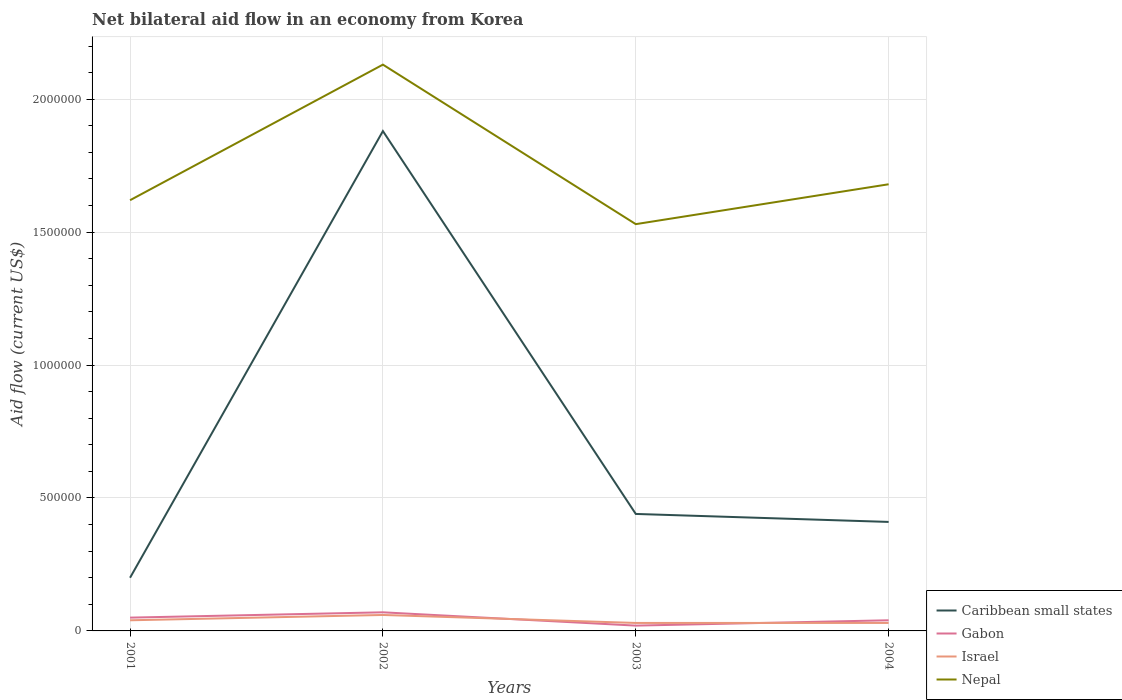How many different coloured lines are there?
Keep it short and to the point. 4. Does the line corresponding to Nepal intersect with the line corresponding to Gabon?
Your answer should be very brief. No. Across all years, what is the maximum net bilateral aid flow in Nepal?
Keep it short and to the point. 1.53e+06. In which year was the net bilateral aid flow in Israel maximum?
Provide a short and direct response. 2003. Is the net bilateral aid flow in Gabon strictly greater than the net bilateral aid flow in Israel over the years?
Provide a short and direct response. No. How many lines are there?
Ensure brevity in your answer.  4. What is the difference between two consecutive major ticks on the Y-axis?
Offer a terse response. 5.00e+05. Are the values on the major ticks of Y-axis written in scientific E-notation?
Provide a succinct answer. No. How many legend labels are there?
Your answer should be very brief. 4. What is the title of the graph?
Make the answer very short. Net bilateral aid flow in an economy from Korea. What is the label or title of the X-axis?
Ensure brevity in your answer.  Years. What is the Aid flow (current US$) in Caribbean small states in 2001?
Make the answer very short. 2.00e+05. What is the Aid flow (current US$) in Israel in 2001?
Keep it short and to the point. 4.00e+04. What is the Aid flow (current US$) of Nepal in 2001?
Your answer should be compact. 1.62e+06. What is the Aid flow (current US$) of Caribbean small states in 2002?
Offer a very short reply. 1.88e+06. What is the Aid flow (current US$) in Nepal in 2002?
Make the answer very short. 2.13e+06. What is the Aid flow (current US$) in Caribbean small states in 2003?
Your response must be concise. 4.40e+05. What is the Aid flow (current US$) of Gabon in 2003?
Your answer should be compact. 2.00e+04. What is the Aid flow (current US$) of Israel in 2003?
Ensure brevity in your answer.  3.00e+04. What is the Aid flow (current US$) in Nepal in 2003?
Make the answer very short. 1.53e+06. What is the Aid flow (current US$) of Caribbean small states in 2004?
Make the answer very short. 4.10e+05. What is the Aid flow (current US$) of Gabon in 2004?
Ensure brevity in your answer.  4.00e+04. What is the Aid flow (current US$) in Nepal in 2004?
Make the answer very short. 1.68e+06. Across all years, what is the maximum Aid flow (current US$) in Caribbean small states?
Your answer should be compact. 1.88e+06. Across all years, what is the maximum Aid flow (current US$) in Israel?
Ensure brevity in your answer.  6.00e+04. Across all years, what is the maximum Aid flow (current US$) in Nepal?
Provide a short and direct response. 2.13e+06. Across all years, what is the minimum Aid flow (current US$) in Gabon?
Give a very brief answer. 2.00e+04. Across all years, what is the minimum Aid flow (current US$) in Israel?
Your response must be concise. 3.00e+04. Across all years, what is the minimum Aid flow (current US$) of Nepal?
Offer a very short reply. 1.53e+06. What is the total Aid flow (current US$) of Caribbean small states in the graph?
Provide a short and direct response. 2.93e+06. What is the total Aid flow (current US$) of Gabon in the graph?
Offer a terse response. 1.80e+05. What is the total Aid flow (current US$) of Israel in the graph?
Provide a short and direct response. 1.60e+05. What is the total Aid flow (current US$) of Nepal in the graph?
Your response must be concise. 6.96e+06. What is the difference between the Aid flow (current US$) of Caribbean small states in 2001 and that in 2002?
Provide a succinct answer. -1.68e+06. What is the difference between the Aid flow (current US$) in Israel in 2001 and that in 2002?
Ensure brevity in your answer.  -2.00e+04. What is the difference between the Aid flow (current US$) of Nepal in 2001 and that in 2002?
Offer a very short reply. -5.10e+05. What is the difference between the Aid flow (current US$) of Gabon in 2001 and that in 2003?
Provide a short and direct response. 3.00e+04. What is the difference between the Aid flow (current US$) in Israel in 2001 and that in 2003?
Your response must be concise. 10000. What is the difference between the Aid flow (current US$) in Caribbean small states in 2001 and that in 2004?
Provide a short and direct response. -2.10e+05. What is the difference between the Aid flow (current US$) of Israel in 2001 and that in 2004?
Keep it short and to the point. 10000. What is the difference between the Aid flow (current US$) in Caribbean small states in 2002 and that in 2003?
Keep it short and to the point. 1.44e+06. What is the difference between the Aid flow (current US$) of Gabon in 2002 and that in 2003?
Offer a terse response. 5.00e+04. What is the difference between the Aid flow (current US$) in Caribbean small states in 2002 and that in 2004?
Give a very brief answer. 1.47e+06. What is the difference between the Aid flow (current US$) in Nepal in 2002 and that in 2004?
Offer a very short reply. 4.50e+05. What is the difference between the Aid flow (current US$) of Caribbean small states in 2003 and that in 2004?
Your answer should be very brief. 3.00e+04. What is the difference between the Aid flow (current US$) of Gabon in 2003 and that in 2004?
Your response must be concise. -2.00e+04. What is the difference between the Aid flow (current US$) in Nepal in 2003 and that in 2004?
Provide a short and direct response. -1.50e+05. What is the difference between the Aid flow (current US$) in Caribbean small states in 2001 and the Aid flow (current US$) in Nepal in 2002?
Your response must be concise. -1.93e+06. What is the difference between the Aid flow (current US$) of Gabon in 2001 and the Aid flow (current US$) of Israel in 2002?
Give a very brief answer. -10000. What is the difference between the Aid flow (current US$) of Gabon in 2001 and the Aid flow (current US$) of Nepal in 2002?
Keep it short and to the point. -2.08e+06. What is the difference between the Aid flow (current US$) in Israel in 2001 and the Aid flow (current US$) in Nepal in 2002?
Make the answer very short. -2.09e+06. What is the difference between the Aid flow (current US$) of Caribbean small states in 2001 and the Aid flow (current US$) of Gabon in 2003?
Give a very brief answer. 1.80e+05. What is the difference between the Aid flow (current US$) of Caribbean small states in 2001 and the Aid flow (current US$) of Israel in 2003?
Provide a succinct answer. 1.70e+05. What is the difference between the Aid flow (current US$) in Caribbean small states in 2001 and the Aid flow (current US$) in Nepal in 2003?
Your answer should be very brief. -1.33e+06. What is the difference between the Aid flow (current US$) in Gabon in 2001 and the Aid flow (current US$) in Israel in 2003?
Your answer should be very brief. 2.00e+04. What is the difference between the Aid flow (current US$) of Gabon in 2001 and the Aid flow (current US$) of Nepal in 2003?
Keep it short and to the point. -1.48e+06. What is the difference between the Aid flow (current US$) of Israel in 2001 and the Aid flow (current US$) of Nepal in 2003?
Provide a succinct answer. -1.49e+06. What is the difference between the Aid flow (current US$) of Caribbean small states in 2001 and the Aid flow (current US$) of Gabon in 2004?
Your response must be concise. 1.60e+05. What is the difference between the Aid flow (current US$) of Caribbean small states in 2001 and the Aid flow (current US$) of Nepal in 2004?
Keep it short and to the point. -1.48e+06. What is the difference between the Aid flow (current US$) of Gabon in 2001 and the Aid flow (current US$) of Israel in 2004?
Offer a terse response. 2.00e+04. What is the difference between the Aid flow (current US$) of Gabon in 2001 and the Aid flow (current US$) of Nepal in 2004?
Ensure brevity in your answer.  -1.63e+06. What is the difference between the Aid flow (current US$) in Israel in 2001 and the Aid flow (current US$) in Nepal in 2004?
Offer a very short reply. -1.64e+06. What is the difference between the Aid flow (current US$) in Caribbean small states in 2002 and the Aid flow (current US$) in Gabon in 2003?
Make the answer very short. 1.86e+06. What is the difference between the Aid flow (current US$) of Caribbean small states in 2002 and the Aid flow (current US$) of Israel in 2003?
Your answer should be compact. 1.85e+06. What is the difference between the Aid flow (current US$) of Gabon in 2002 and the Aid flow (current US$) of Nepal in 2003?
Your answer should be very brief. -1.46e+06. What is the difference between the Aid flow (current US$) in Israel in 2002 and the Aid flow (current US$) in Nepal in 2003?
Ensure brevity in your answer.  -1.47e+06. What is the difference between the Aid flow (current US$) in Caribbean small states in 2002 and the Aid flow (current US$) in Gabon in 2004?
Give a very brief answer. 1.84e+06. What is the difference between the Aid flow (current US$) in Caribbean small states in 2002 and the Aid flow (current US$) in Israel in 2004?
Offer a terse response. 1.85e+06. What is the difference between the Aid flow (current US$) of Gabon in 2002 and the Aid flow (current US$) of Israel in 2004?
Provide a succinct answer. 4.00e+04. What is the difference between the Aid flow (current US$) of Gabon in 2002 and the Aid flow (current US$) of Nepal in 2004?
Your answer should be very brief. -1.61e+06. What is the difference between the Aid flow (current US$) in Israel in 2002 and the Aid flow (current US$) in Nepal in 2004?
Provide a succinct answer. -1.62e+06. What is the difference between the Aid flow (current US$) in Caribbean small states in 2003 and the Aid flow (current US$) in Israel in 2004?
Your answer should be compact. 4.10e+05. What is the difference between the Aid flow (current US$) in Caribbean small states in 2003 and the Aid flow (current US$) in Nepal in 2004?
Your answer should be very brief. -1.24e+06. What is the difference between the Aid flow (current US$) of Gabon in 2003 and the Aid flow (current US$) of Nepal in 2004?
Provide a short and direct response. -1.66e+06. What is the difference between the Aid flow (current US$) of Israel in 2003 and the Aid flow (current US$) of Nepal in 2004?
Give a very brief answer. -1.65e+06. What is the average Aid flow (current US$) of Caribbean small states per year?
Give a very brief answer. 7.32e+05. What is the average Aid flow (current US$) of Gabon per year?
Ensure brevity in your answer.  4.50e+04. What is the average Aid flow (current US$) of Israel per year?
Ensure brevity in your answer.  4.00e+04. What is the average Aid flow (current US$) in Nepal per year?
Keep it short and to the point. 1.74e+06. In the year 2001, what is the difference between the Aid flow (current US$) of Caribbean small states and Aid flow (current US$) of Israel?
Your answer should be compact. 1.60e+05. In the year 2001, what is the difference between the Aid flow (current US$) in Caribbean small states and Aid flow (current US$) in Nepal?
Your answer should be compact. -1.42e+06. In the year 2001, what is the difference between the Aid flow (current US$) of Gabon and Aid flow (current US$) of Israel?
Keep it short and to the point. 10000. In the year 2001, what is the difference between the Aid flow (current US$) of Gabon and Aid flow (current US$) of Nepal?
Offer a terse response. -1.57e+06. In the year 2001, what is the difference between the Aid flow (current US$) of Israel and Aid flow (current US$) of Nepal?
Ensure brevity in your answer.  -1.58e+06. In the year 2002, what is the difference between the Aid flow (current US$) in Caribbean small states and Aid flow (current US$) in Gabon?
Make the answer very short. 1.81e+06. In the year 2002, what is the difference between the Aid flow (current US$) of Caribbean small states and Aid flow (current US$) of Israel?
Ensure brevity in your answer.  1.82e+06. In the year 2002, what is the difference between the Aid flow (current US$) in Caribbean small states and Aid flow (current US$) in Nepal?
Give a very brief answer. -2.50e+05. In the year 2002, what is the difference between the Aid flow (current US$) in Gabon and Aid flow (current US$) in Nepal?
Provide a succinct answer. -2.06e+06. In the year 2002, what is the difference between the Aid flow (current US$) of Israel and Aid flow (current US$) of Nepal?
Your response must be concise. -2.07e+06. In the year 2003, what is the difference between the Aid flow (current US$) of Caribbean small states and Aid flow (current US$) of Gabon?
Offer a very short reply. 4.20e+05. In the year 2003, what is the difference between the Aid flow (current US$) in Caribbean small states and Aid flow (current US$) in Nepal?
Your answer should be very brief. -1.09e+06. In the year 2003, what is the difference between the Aid flow (current US$) of Gabon and Aid flow (current US$) of Israel?
Keep it short and to the point. -10000. In the year 2003, what is the difference between the Aid flow (current US$) of Gabon and Aid flow (current US$) of Nepal?
Offer a very short reply. -1.51e+06. In the year 2003, what is the difference between the Aid flow (current US$) in Israel and Aid flow (current US$) in Nepal?
Provide a succinct answer. -1.50e+06. In the year 2004, what is the difference between the Aid flow (current US$) of Caribbean small states and Aid flow (current US$) of Nepal?
Your response must be concise. -1.27e+06. In the year 2004, what is the difference between the Aid flow (current US$) of Gabon and Aid flow (current US$) of Nepal?
Offer a terse response. -1.64e+06. In the year 2004, what is the difference between the Aid flow (current US$) of Israel and Aid flow (current US$) of Nepal?
Your answer should be compact. -1.65e+06. What is the ratio of the Aid flow (current US$) of Caribbean small states in 2001 to that in 2002?
Make the answer very short. 0.11. What is the ratio of the Aid flow (current US$) of Gabon in 2001 to that in 2002?
Your response must be concise. 0.71. What is the ratio of the Aid flow (current US$) in Israel in 2001 to that in 2002?
Offer a very short reply. 0.67. What is the ratio of the Aid flow (current US$) in Nepal in 2001 to that in 2002?
Your answer should be compact. 0.76. What is the ratio of the Aid flow (current US$) in Caribbean small states in 2001 to that in 2003?
Make the answer very short. 0.45. What is the ratio of the Aid flow (current US$) of Israel in 2001 to that in 2003?
Give a very brief answer. 1.33. What is the ratio of the Aid flow (current US$) of Nepal in 2001 to that in 2003?
Provide a succinct answer. 1.06. What is the ratio of the Aid flow (current US$) of Caribbean small states in 2001 to that in 2004?
Keep it short and to the point. 0.49. What is the ratio of the Aid flow (current US$) of Israel in 2001 to that in 2004?
Ensure brevity in your answer.  1.33. What is the ratio of the Aid flow (current US$) in Nepal in 2001 to that in 2004?
Your response must be concise. 0.96. What is the ratio of the Aid flow (current US$) of Caribbean small states in 2002 to that in 2003?
Give a very brief answer. 4.27. What is the ratio of the Aid flow (current US$) in Nepal in 2002 to that in 2003?
Keep it short and to the point. 1.39. What is the ratio of the Aid flow (current US$) of Caribbean small states in 2002 to that in 2004?
Give a very brief answer. 4.59. What is the ratio of the Aid flow (current US$) in Gabon in 2002 to that in 2004?
Ensure brevity in your answer.  1.75. What is the ratio of the Aid flow (current US$) in Nepal in 2002 to that in 2004?
Provide a short and direct response. 1.27. What is the ratio of the Aid flow (current US$) in Caribbean small states in 2003 to that in 2004?
Your answer should be very brief. 1.07. What is the ratio of the Aid flow (current US$) of Gabon in 2003 to that in 2004?
Make the answer very short. 0.5. What is the ratio of the Aid flow (current US$) in Nepal in 2003 to that in 2004?
Your answer should be compact. 0.91. What is the difference between the highest and the second highest Aid flow (current US$) in Caribbean small states?
Your response must be concise. 1.44e+06. What is the difference between the highest and the second highest Aid flow (current US$) in Gabon?
Provide a short and direct response. 2.00e+04. What is the difference between the highest and the lowest Aid flow (current US$) in Caribbean small states?
Make the answer very short. 1.68e+06. What is the difference between the highest and the lowest Aid flow (current US$) in Nepal?
Give a very brief answer. 6.00e+05. 